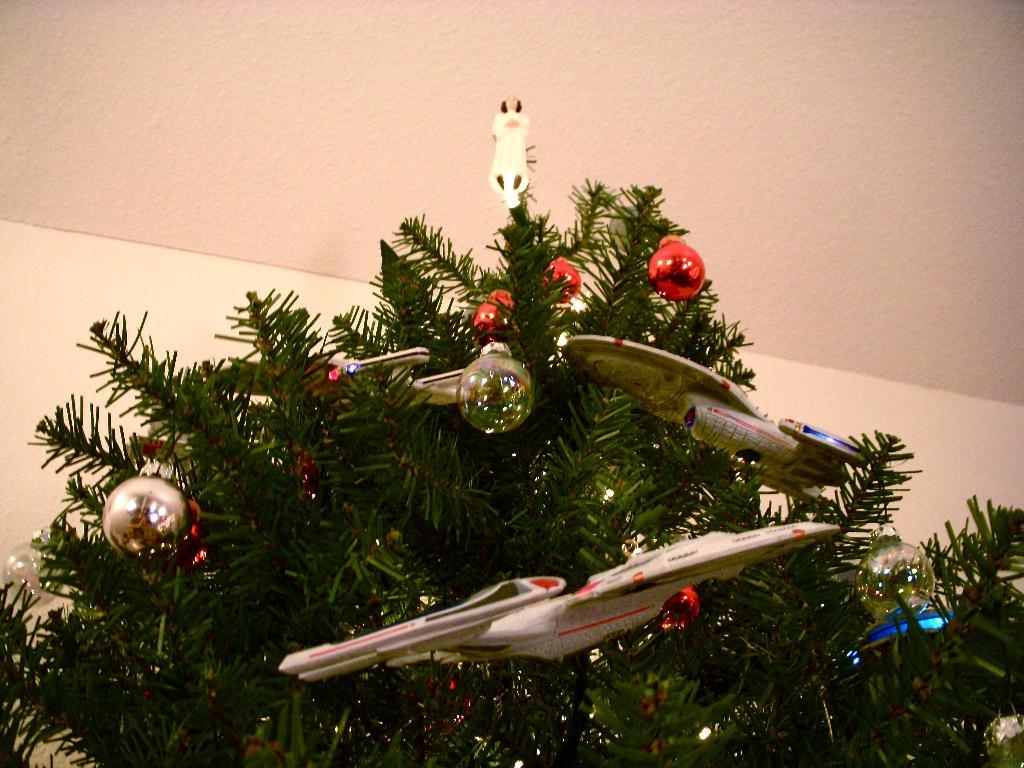What is the main subject of the image? There is a Christmas tree in the image. What can be seen on the Christmas tree? There are objects on the Christmas tree. What is visible in the background of the image? There is a ceiling visible in the background of the image. What type of pie is being served on the table in the image? There is no table or pie present in the image; it only features a Christmas tree and a ceiling. 